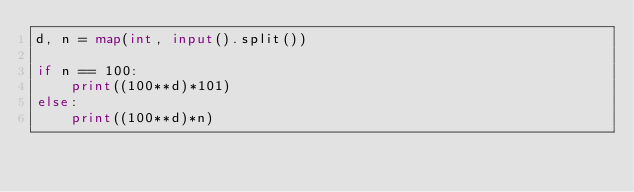<code> <loc_0><loc_0><loc_500><loc_500><_Python_>d, n = map(int, input().split())

if n == 100:
    print((100**d)*101)
else:
    print((100**d)*n)</code> 